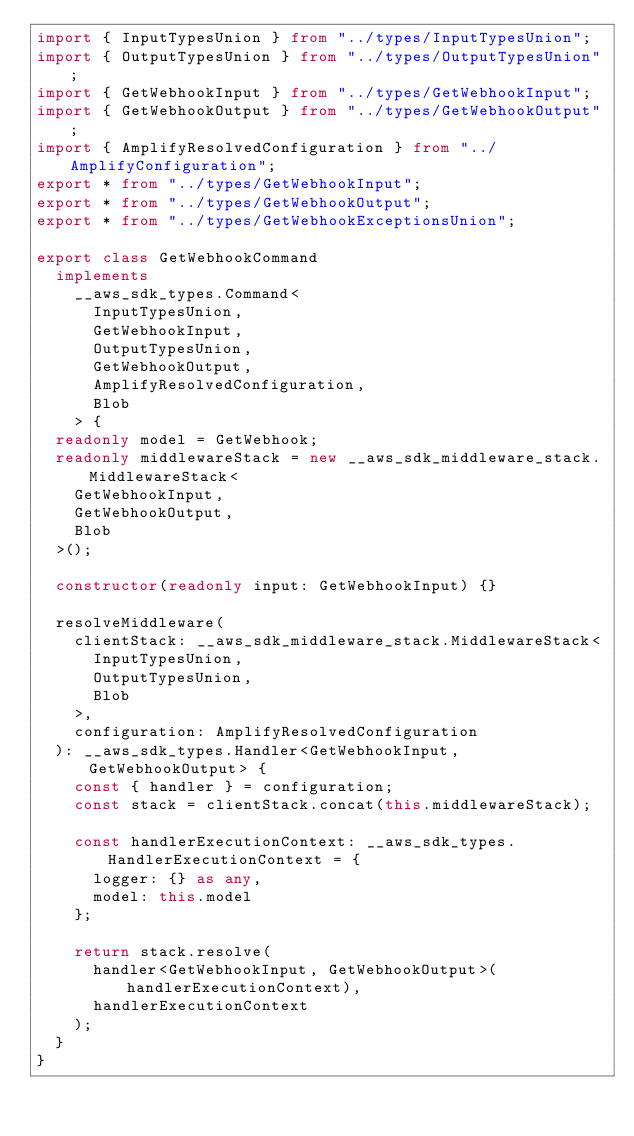<code> <loc_0><loc_0><loc_500><loc_500><_TypeScript_>import { InputTypesUnion } from "../types/InputTypesUnion";
import { OutputTypesUnion } from "../types/OutputTypesUnion";
import { GetWebhookInput } from "../types/GetWebhookInput";
import { GetWebhookOutput } from "../types/GetWebhookOutput";
import { AmplifyResolvedConfiguration } from "../AmplifyConfiguration";
export * from "../types/GetWebhookInput";
export * from "../types/GetWebhookOutput";
export * from "../types/GetWebhookExceptionsUnion";

export class GetWebhookCommand
  implements
    __aws_sdk_types.Command<
      InputTypesUnion,
      GetWebhookInput,
      OutputTypesUnion,
      GetWebhookOutput,
      AmplifyResolvedConfiguration,
      Blob
    > {
  readonly model = GetWebhook;
  readonly middlewareStack = new __aws_sdk_middleware_stack.MiddlewareStack<
    GetWebhookInput,
    GetWebhookOutput,
    Blob
  >();

  constructor(readonly input: GetWebhookInput) {}

  resolveMiddleware(
    clientStack: __aws_sdk_middleware_stack.MiddlewareStack<
      InputTypesUnion,
      OutputTypesUnion,
      Blob
    >,
    configuration: AmplifyResolvedConfiguration
  ): __aws_sdk_types.Handler<GetWebhookInput, GetWebhookOutput> {
    const { handler } = configuration;
    const stack = clientStack.concat(this.middlewareStack);

    const handlerExecutionContext: __aws_sdk_types.HandlerExecutionContext = {
      logger: {} as any,
      model: this.model
    };

    return stack.resolve(
      handler<GetWebhookInput, GetWebhookOutput>(handlerExecutionContext),
      handlerExecutionContext
    );
  }
}
</code> 